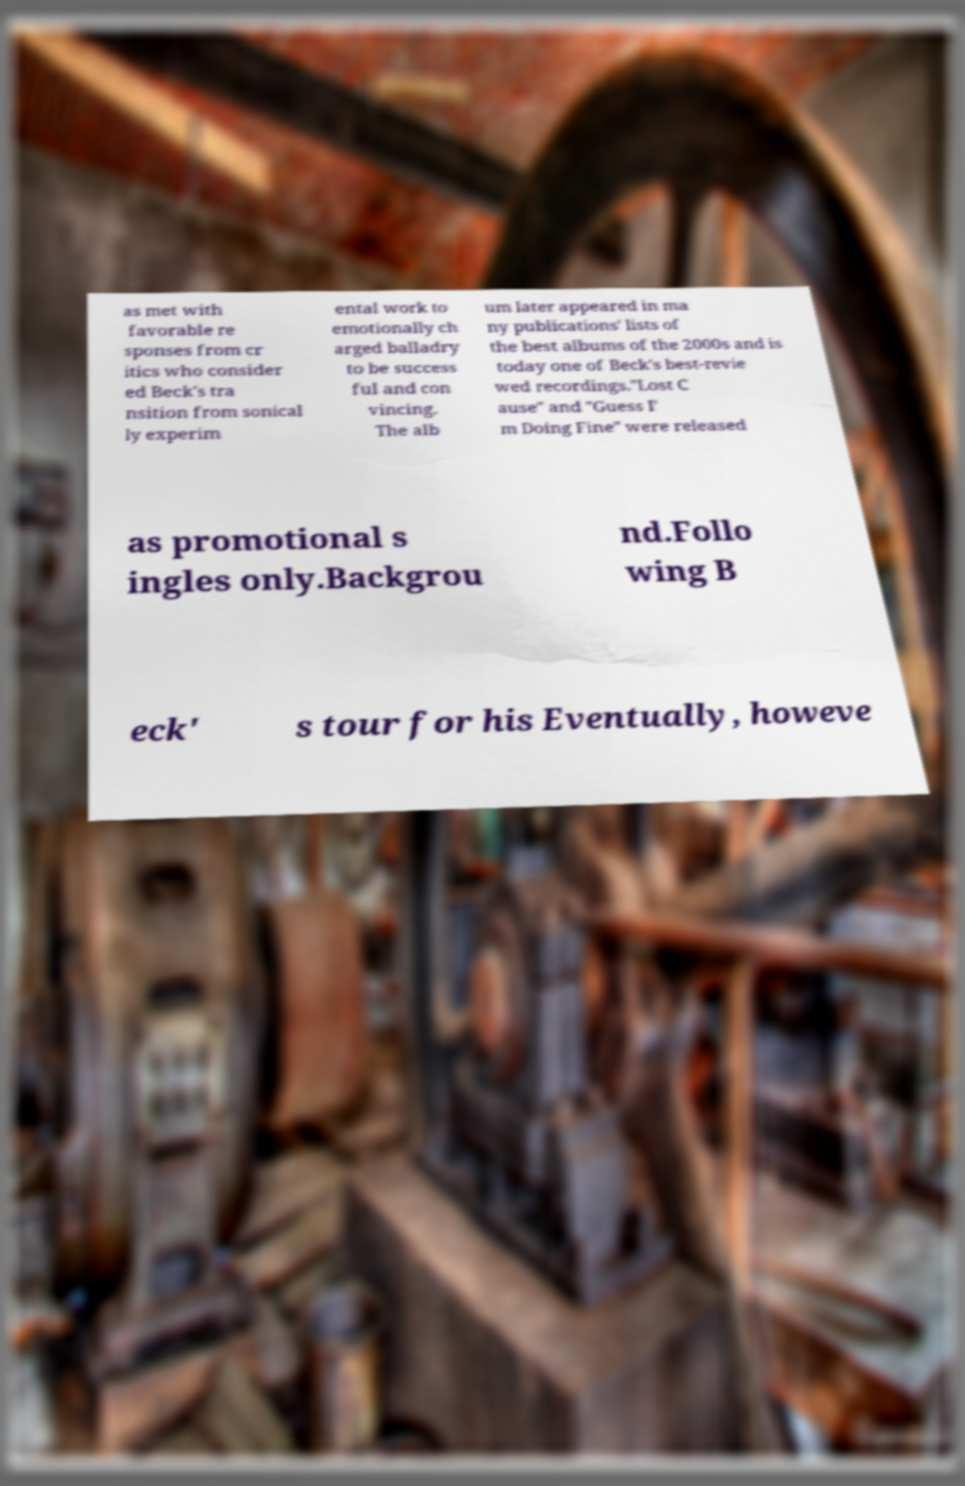There's text embedded in this image that I need extracted. Can you transcribe it verbatim? as met with favorable re sponses from cr itics who consider ed Beck's tra nsition from sonical ly experim ental work to emotionally ch arged balladry to be success ful and con vincing. The alb um later appeared in ma ny publications' lists of the best albums of the 2000s and is today one of Beck's best-revie wed recordings."Lost C ause" and "Guess I' m Doing Fine" were released as promotional s ingles only.Backgrou nd.Follo wing B eck' s tour for his Eventually, howeve 